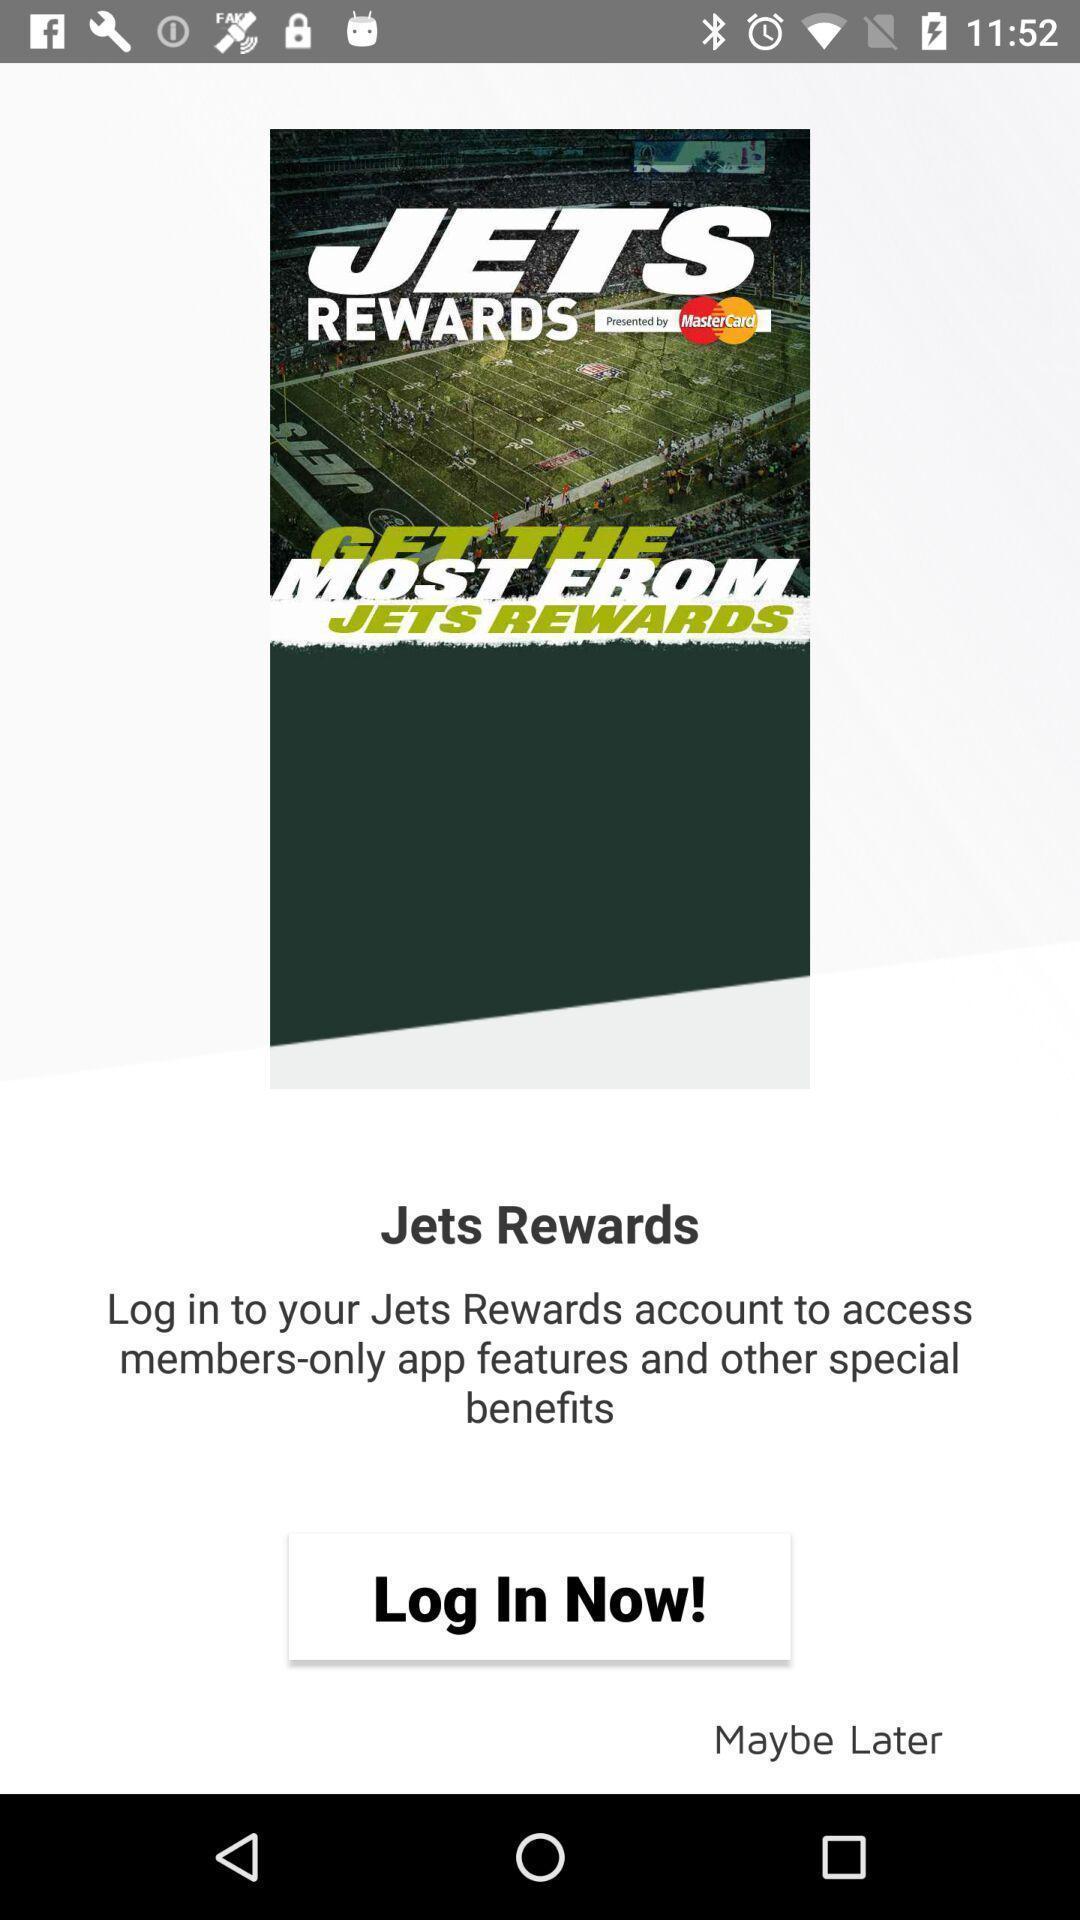Provide a textual representation of this image. Page displaying login option. 